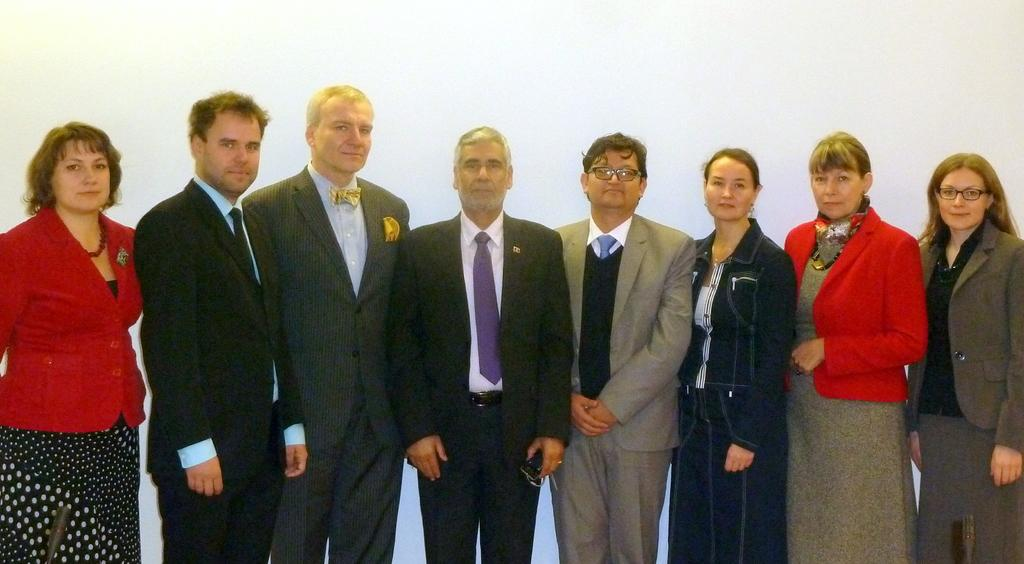How many people are in the image? There is a group of people in the image. What are the people in the image doing? The people are standing. Can you describe any specific features of the people in the image? Some people in the group are wearing spectacles. What objects can be seen in the image besides the people? There are microphones visible in the image. What type of disgust can be seen on the faces of the people in the image? There is no indication of disgust on the faces of the people in the image. 